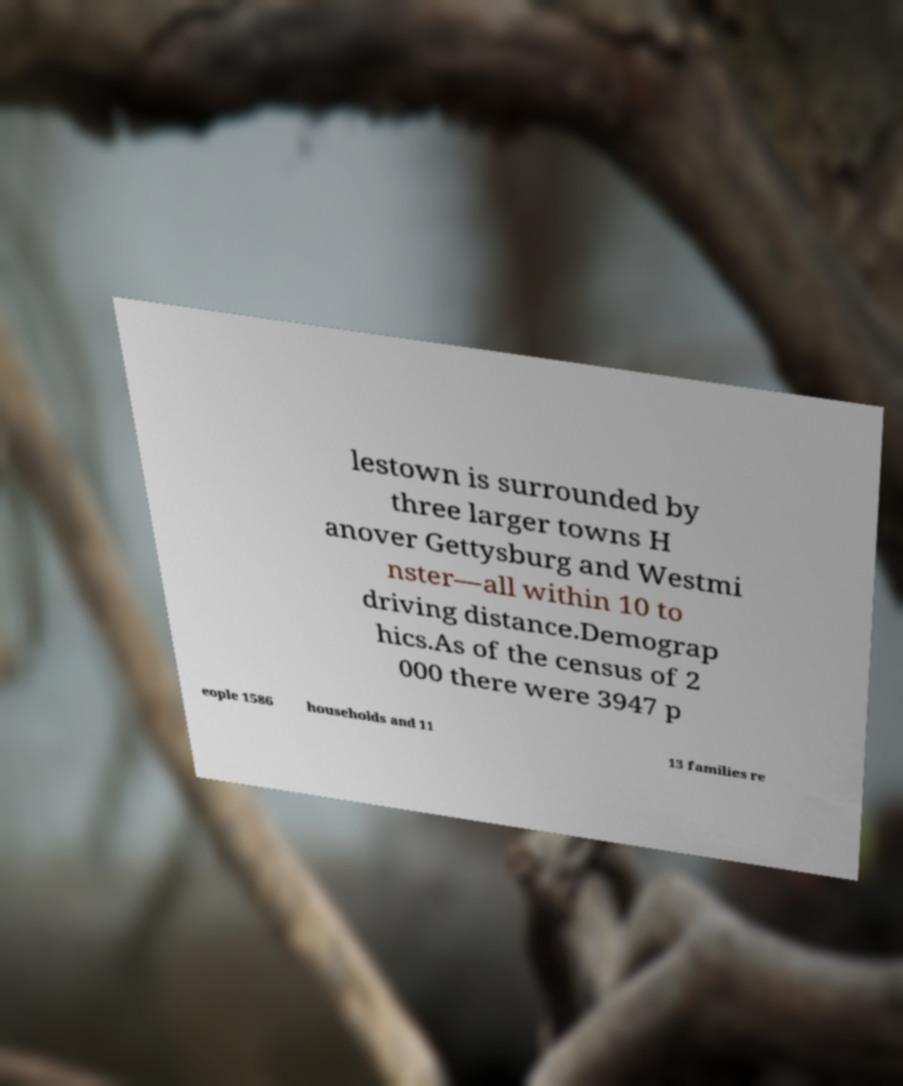Please identify and transcribe the text found in this image. lestown is surrounded by three larger towns H anover Gettysburg and Westmi nster—all within 10 to driving distance.Demograp hics.As of the census of 2 000 there were 3947 p eople 1586 households and 11 13 families re 